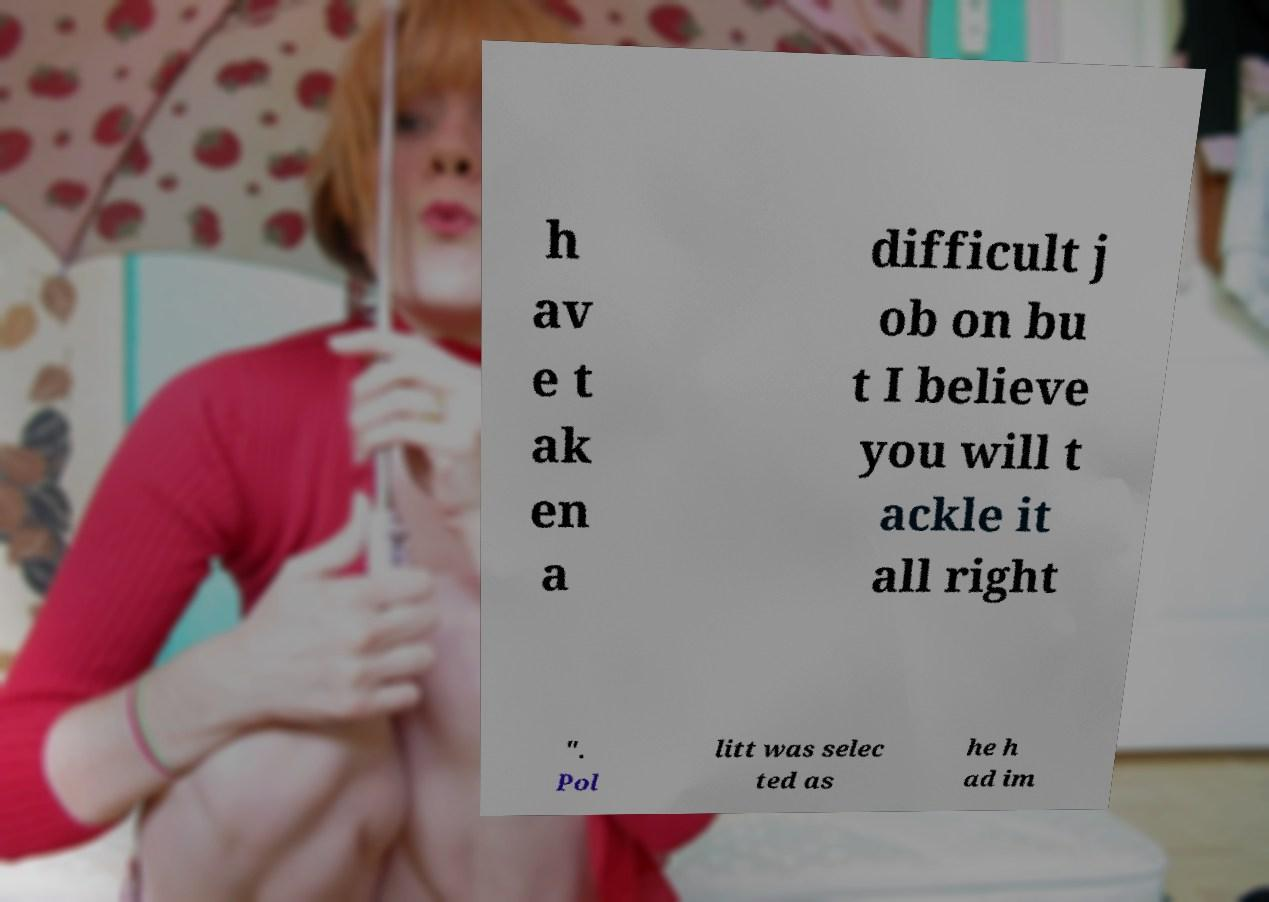Can you accurately transcribe the text from the provided image for me? h av e t ak en a difficult j ob on bu t I believe you will t ackle it all right ". Pol litt was selec ted as he h ad im 